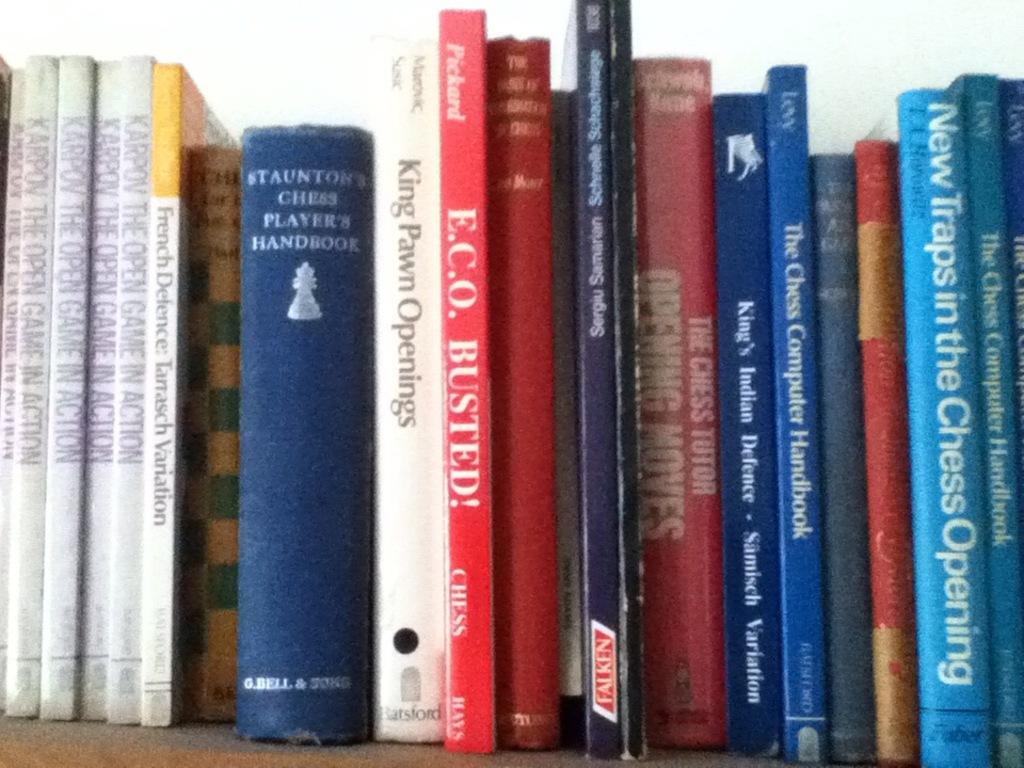What are these books mostly about?
Keep it short and to the point. Chess. 